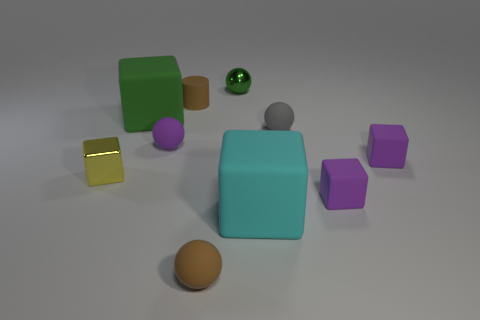Is the block behind the gray rubber sphere made of the same material as the cylinder?
Keep it short and to the point. Yes. Is there any other thing that has the same size as the green rubber object?
Offer a very short reply. Yes. What material is the tiny yellow block that is in front of the matte cylinder that is behind the cyan thing?
Your answer should be compact. Metal. Are there more purple balls that are right of the tiny purple ball than tiny purple blocks that are to the left of the green matte object?
Provide a short and direct response. No. The brown rubber cylinder has what size?
Ensure brevity in your answer.  Small. Does the large rubber thing right of the small green sphere have the same color as the tiny cylinder?
Offer a terse response. No. Are there any other things that are the same shape as the cyan object?
Your answer should be very brief. Yes. There is a brown thing that is behind the brown matte ball; are there any cubes that are to the right of it?
Ensure brevity in your answer.  Yes. Are there fewer large cyan rubber objects on the left side of the brown rubber cylinder than large cyan rubber objects behind the small green sphere?
Your response must be concise. No. There is a brown object that is in front of the rubber ball on the right side of the large cyan object behind the brown rubber ball; what size is it?
Provide a succinct answer. Small. 